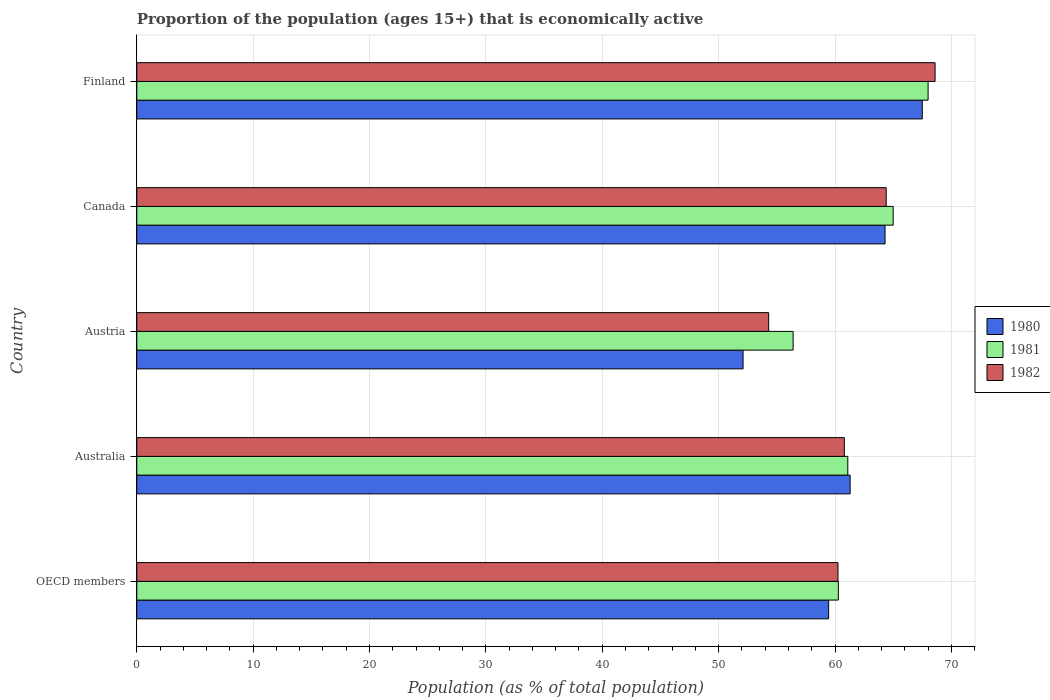Are the number of bars on each tick of the Y-axis equal?
Give a very brief answer. Yes. What is the label of the 1st group of bars from the top?
Give a very brief answer. Finland. In how many cases, is the number of bars for a given country not equal to the number of legend labels?
Make the answer very short. 0. What is the proportion of the population that is economically active in 1981 in Finland?
Your answer should be compact. 68. Across all countries, what is the minimum proportion of the population that is economically active in 1980?
Give a very brief answer. 52.1. In which country was the proportion of the population that is economically active in 1980 maximum?
Offer a very short reply. Finland. What is the total proportion of the population that is economically active in 1982 in the graph?
Your answer should be compact. 308.35. What is the difference between the proportion of the population that is economically active in 1982 in Australia and that in Finland?
Your answer should be compact. -7.8. What is the difference between the proportion of the population that is economically active in 1981 in Finland and the proportion of the population that is economically active in 1982 in OECD members?
Your answer should be very brief. 7.75. What is the average proportion of the population that is economically active in 1981 per country?
Your answer should be compact. 62.16. What is the difference between the proportion of the population that is economically active in 1982 and proportion of the population that is economically active in 1980 in Canada?
Give a very brief answer. 0.1. In how many countries, is the proportion of the population that is economically active in 1980 greater than 20 %?
Ensure brevity in your answer.  5. What is the ratio of the proportion of the population that is economically active in 1982 in Australia to that in Canada?
Provide a short and direct response. 0.94. Is the proportion of the population that is economically active in 1982 in Australia less than that in OECD members?
Give a very brief answer. No. Is the difference between the proportion of the population that is economically active in 1982 in Australia and OECD members greater than the difference between the proportion of the population that is economically active in 1980 in Australia and OECD members?
Provide a succinct answer. No. What is the difference between the highest and the second highest proportion of the population that is economically active in 1980?
Your answer should be compact. 3.2. What is the difference between the highest and the lowest proportion of the population that is economically active in 1980?
Your answer should be compact. 15.4. Is the sum of the proportion of the population that is economically active in 1980 in Australia and OECD members greater than the maximum proportion of the population that is economically active in 1981 across all countries?
Provide a short and direct response. Yes. What does the 2nd bar from the top in Canada represents?
Your answer should be very brief. 1981. What does the 2nd bar from the bottom in Austria represents?
Offer a very short reply. 1981. Are all the bars in the graph horizontal?
Ensure brevity in your answer.  Yes. How many countries are there in the graph?
Your response must be concise. 5. Are the values on the major ticks of X-axis written in scientific E-notation?
Provide a succinct answer. No. Does the graph contain grids?
Give a very brief answer. Yes. Where does the legend appear in the graph?
Offer a terse response. Center right. How are the legend labels stacked?
Offer a terse response. Vertical. What is the title of the graph?
Make the answer very short. Proportion of the population (ages 15+) that is economically active. What is the label or title of the X-axis?
Offer a terse response. Population (as % of total population). What is the Population (as % of total population) in 1980 in OECD members?
Give a very brief answer. 59.45. What is the Population (as % of total population) of 1981 in OECD members?
Ensure brevity in your answer.  60.29. What is the Population (as % of total population) of 1982 in OECD members?
Give a very brief answer. 60.25. What is the Population (as % of total population) in 1980 in Australia?
Ensure brevity in your answer.  61.3. What is the Population (as % of total population) of 1981 in Australia?
Offer a very short reply. 61.1. What is the Population (as % of total population) of 1982 in Australia?
Your response must be concise. 60.8. What is the Population (as % of total population) of 1980 in Austria?
Your response must be concise. 52.1. What is the Population (as % of total population) in 1981 in Austria?
Offer a terse response. 56.4. What is the Population (as % of total population) in 1982 in Austria?
Your answer should be compact. 54.3. What is the Population (as % of total population) in 1980 in Canada?
Provide a short and direct response. 64.3. What is the Population (as % of total population) in 1982 in Canada?
Provide a succinct answer. 64.4. What is the Population (as % of total population) of 1980 in Finland?
Offer a terse response. 67.5. What is the Population (as % of total population) in 1982 in Finland?
Your response must be concise. 68.6. Across all countries, what is the maximum Population (as % of total population) of 1980?
Your answer should be compact. 67.5. Across all countries, what is the maximum Population (as % of total population) in 1982?
Give a very brief answer. 68.6. Across all countries, what is the minimum Population (as % of total population) of 1980?
Provide a short and direct response. 52.1. Across all countries, what is the minimum Population (as % of total population) in 1981?
Your answer should be compact. 56.4. Across all countries, what is the minimum Population (as % of total population) of 1982?
Offer a terse response. 54.3. What is the total Population (as % of total population) in 1980 in the graph?
Make the answer very short. 304.65. What is the total Population (as % of total population) of 1981 in the graph?
Give a very brief answer. 310.79. What is the total Population (as % of total population) of 1982 in the graph?
Ensure brevity in your answer.  308.35. What is the difference between the Population (as % of total population) in 1980 in OECD members and that in Australia?
Make the answer very short. -1.85. What is the difference between the Population (as % of total population) of 1981 in OECD members and that in Australia?
Keep it short and to the point. -0.81. What is the difference between the Population (as % of total population) in 1982 in OECD members and that in Australia?
Offer a terse response. -0.55. What is the difference between the Population (as % of total population) of 1980 in OECD members and that in Austria?
Your answer should be compact. 7.35. What is the difference between the Population (as % of total population) of 1981 in OECD members and that in Austria?
Your answer should be compact. 3.89. What is the difference between the Population (as % of total population) in 1982 in OECD members and that in Austria?
Keep it short and to the point. 5.95. What is the difference between the Population (as % of total population) in 1980 in OECD members and that in Canada?
Your response must be concise. -4.85. What is the difference between the Population (as % of total population) in 1981 in OECD members and that in Canada?
Give a very brief answer. -4.71. What is the difference between the Population (as % of total population) in 1982 in OECD members and that in Canada?
Offer a very short reply. -4.15. What is the difference between the Population (as % of total population) of 1980 in OECD members and that in Finland?
Your answer should be compact. -8.05. What is the difference between the Population (as % of total population) in 1981 in OECD members and that in Finland?
Make the answer very short. -7.71. What is the difference between the Population (as % of total population) of 1982 in OECD members and that in Finland?
Your response must be concise. -8.35. What is the difference between the Population (as % of total population) of 1981 in Australia and that in Austria?
Provide a succinct answer. 4.7. What is the difference between the Population (as % of total population) of 1980 in Australia and that in Canada?
Offer a terse response. -3. What is the difference between the Population (as % of total population) of 1982 in Australia and that in Canada?
Your answer should be compact. -3.6. What is the difference between the Population (as % of total population) of 1980 in Australia and that in Finland?
Provide a succinct answer. -6.2. What is the difference between the Population (as % of total population) in 1981 in Australia and that in Finland?
Give a very brief answer. -6.9. What is the difference between the Population (as % of total population) of 1980 in Austria and that in Canada?
Offer a very short reply. -12.2. What is the difference between the Population (as % of total population) in 1981 in Austria and that in Canada?
Provide a short and direct response. -8.6. What is the difference between the Population (as % of total population) of 1980 in Austria and that in Finland?
Offer a terse response. -15.4. What is the difference between the Population (as % of total population) in 1982 in Austria and that in Finland?
Offer a terse response. -14.3. What is the difference between the Population (as % of total population) in 1980 in OECD members and the Population (as % of total population) in 1981 in Australia?
Offer a very short reply. -1.65. What is the difference between the Population (as % of total population) in 1980 in OECD members and the Population (as % of total population) in 1982 in Australia?
Provide a short and direct response. -1.35. What is the difference between the Population (as % of total population) in 1981 in OECD members and the Population (as % of total population) in 1982 in Australia?
Offer a very short reply. -0.51. What is the difference between the Population (as % of total population) in 1980 in OECD members and the Population (as % of total population) in 1981 in Austria?
Your answer should be very brief. 3.05. What is the difference between the Population (as % of total population) of 1980 in OECD members and the Population (as % of total population) of 1982 in Austria?
Your response must be concise. 5.15. What is the difference between the Population (as % of total population) of 1981 in OECD members and the Population (as % of total population) of 1982 in Austria?
Your answer should be very brief. 5.99. What is the difference between the Population (as % of total population) in 1980 in OECD members and the Population (as % of total population) in 1981 in Canada?
Ensure brevity in your answer.  -5.55. What is the difference between the Population (as % of total population) in 1980 in OECD members and the Population (as % of total population) in 1982 in Canada?
Offer a terse response. -4.95. What is the difference between the Population (as % of total population) in 1981 in OECD members and the Population (as % of total population) in 1982 in Canada?
Keep it short and to the point. -4.11. What is the difference between the Population (as % of total population) of 1980 in OECD members and the Population (as % of total population) of 1981 in Finland?
Keep it short and to the point. -8.55. What is the difference between the Population (as % of total population) of 1980 in OECD members and the Population (as % of total population) of 1982 in Finland?
Provide a succinct answer. -9.15. What is the difference between the Population (as % of total population) of 1981 in OECD members and the Population (as % of total population) of 1982 in Finland?
Ensure brevity in your answer.  -8.31. What is the difference between the Population (as % of total population) of 1980 in Australia and the Population (as % of total population) of 1981 in Austria?
Give a very brief answer. 4.9. What is the difference between the Population (as % of total population) of 1980 in Australia and the Population (as % of total population) of 1982 in Austria?
Make the answer very short. 7. What is the difference between the Population (as % of total population) of 1981 in Australia and the Population (as % of total population) of 1982 in Austria?
Your response must be concise. 6.8. What is the difference between the Population (as % of total population) of 1980 in Australia and the Population (as % of total population) of 1981 in Canada?
Keep it short and to the point. -3.7. What is the difference between the Population (as % of total population) of 1980 in Australia and the Population (as % of total population) of 1982 in Canada?
Give a very brief answer. -3.1. What is the difference between the Population (as % of total population) of 1980 in Australia and the Population (as % of total population) of 1981 in Finland?
Give a very brief answer. -6.7. What is the difference between the Population (as % of total population) in 1980 in Austria and the Population (as % of total population) in 1982 in Canada?
Make the answer very short. -12.3. What is the difference between the Population (as % of total population) of 1980 in Austria and the Population (as % of total population) of 1981 in Finland?
Provide a succinct answer. -15.9. What is the difference between the Population (as % of total population) in 1980 in Austria and the Population (as % of total population) in 1982 in Finland?
Provide a short and direct response. -16.5. What is the difference between the Population (as % of total population) of 1981 in Canada and the Population (as % of total population) of 1982 in Finland?
Your answer should be very brief. -3.6. What is the average Population (as % of total population) of 1980 per country?
Your answer should be very brief. 60.93. What is the average Population (as % of total population) in 1981 per country?
Your answer should be compact. 62.16. What is the average Population (as % of total population) in 1982 per country?
Ensure brevity in your answer.  61.67. What is the difference between the Population (as % of total population) in 1980 and Population (as % of total population) in 1981 in OECD members?
Your response must be concise. -0.83. What is the difference between the Population (as % of total population) of 1980 and Population (as % of total population) of 1982 in OECD members?
Keep it short and to the point. -0.8. What is the difference between the Population (as % of total population) of 1981 and Population (as % of total population) of 1982 in OECD members?
Your answer should be compact. 0.03. What is the difference between the Population (as % of total population) of 1980 and Population (as % of total population) of 1982 in Australia?
Give a very brief answer. 0.5. What is the difference between the Population (as % of total population) in 1981 and Population (as % of total population) in 1982 in Australia?
Provide a short and direct response. 0.3. What is the difference between the Population (as % of total population) in 1980 and Population (as % of total population) in 1982 in Austria?
Offer a terse response. -2.2. What is the difference between the Population (as % of total population) of 1980 and Population (as % of total population) of 1981 in Canada?
Your answer should be compact. -0.7. What is the difference between the Population (as % of total population) in 1980 and Population (as % of total population) in 1982 in Canada?
Keep it short and to the point. -0.1. What is the difference between the Population (as % of total population) in 1981 and Population (as % of total population) in 1982 in Finland?
Provide a succinct answer. -0.6. What is the ratio of the Population (as % of total population) in 1980 in OECD members to that in Australia?
Your answer should be compact. 0.97. What is the ratio of the Population (as % of total population) of 1981 in OECD members to that in Australia?
Your answer should be compact. 0.99. What is the ratio of the Population (as % of total population) of 1982 in OECD members to that in Australia?
Ensure brevity in your answer.  0.99. What is the ratio of the Population (as % of total population) of 1980 in OECD members to that in Austria?
Ensure brevity in your answer.  1.14. What is the ratio of the Population (as % of total population) of 1981 in OECD members to that in Austria?
Provide a succinct answer. 1.07. What is the ratio of the Population (as % of total population) of 1982 in OECD members to that in Austria?
Your answer should be compact. 1.11. What is the ratio of the Population (as % of total population) of 1980 in OECD members to that in Canada?
Provide a short and direct response. 0.92. What is the ratio of the Population (as % of total population) of 1981 in OECD members to that in Canada?
Offer a terse response. 0.93. What is the ratio of the Population (as % of total population) of 1982 in OECD members to that in Canada?
Provide a succinct answer. 0.94. What is the ratio of the Population (as % of total population) in 1980 in OECD members to that in Finland?
Provide a short and direct response. 0.88. What is the ratio of the Population (as % of total population) in 1981 in OECD members to that in Finland?
Your answer should be very brief. 0.89. What is the ratio of the Population (as % of total population) of 1982 in OECD members to that in Finland?
Provide a succinct answer. 0.88. What is the ratio of the Population (as % of total population) in 1980 in Australia to that in Austria?
Your response must be concise. 1.18. What is the ratio of the Population (as % of total population) of 1982 in Australia to that in Austria?
Ensure brevity in your answer.  1.12. What is the ratio of the Population (as % of total population) of 1980 in Australia to that in Canada?
Provide a succinct answer. 0.95. What is the ratio of the Population (as % of total population) of 1981 in Australia to that in Canada?
Give a very brief answer. 0.94. What is the ratio of the Population (as % of total population) of 1982 in Australia to that in Canada?
Offer a very short reply. 0.94. What is the ratio of the Population (as % of total population) of 1980 in Australia to that in Finland?
Keep it short and to the point. 0.91. What is the ratio of the Population (as % of total population) in 1981 in Australia to that in Finland?
Keep it short and to the point. 0.9. What is the ratio of the Population (as % of total population) in 1982 in Australia to that in Finland?
Offer a very short reply. 0.89. What is the ratio of the Population (as % of total population) of 1980 in Austria to that in Canada?
Make the answer very short. 0.81. What is the ratio of the Population (as % of total population) of 1981 in Austria to that in Canada?
Make the answer very short. 0.87. What is the ratio of the Population (as % of total population) of 1982 in Austria to that in Canada?
Your answer should be compact. 0.84. What is the ratio of the Population (as % of total population) in 1980 in Austria to that in Finland?
Offer a very short reply. 0.77. What is the ratio of the Population (as % of total population) in 1981 in Austria to that in Finland?
Your answer should be very brief. 0.83. What is the ratio of the Population (as % of total population) in 1982 in Austria to that in Finland?
Your response must be concise. 0.79. What is the ratio of the Population (as % of total population) of 1980 in Canada to that in Finland?
Your response must be concise. 0.95. What is the ratio of the Population (as % of total population) of 1981 in Canada to that in Finland?
Make the answer very short. 0.96. What is the ratio of the Population (as % of total population) in 1982 in Canada to that in Finland?
Your answer should be very brief. 0.94. What is the difference between the highest and the second highest Population (as % of total population) in 1981?
Give a very brief answer. 3. What is the difference between the highest and the lowest Population (as % of total population) in 1980?
Give a very brief answer. 15.4. 